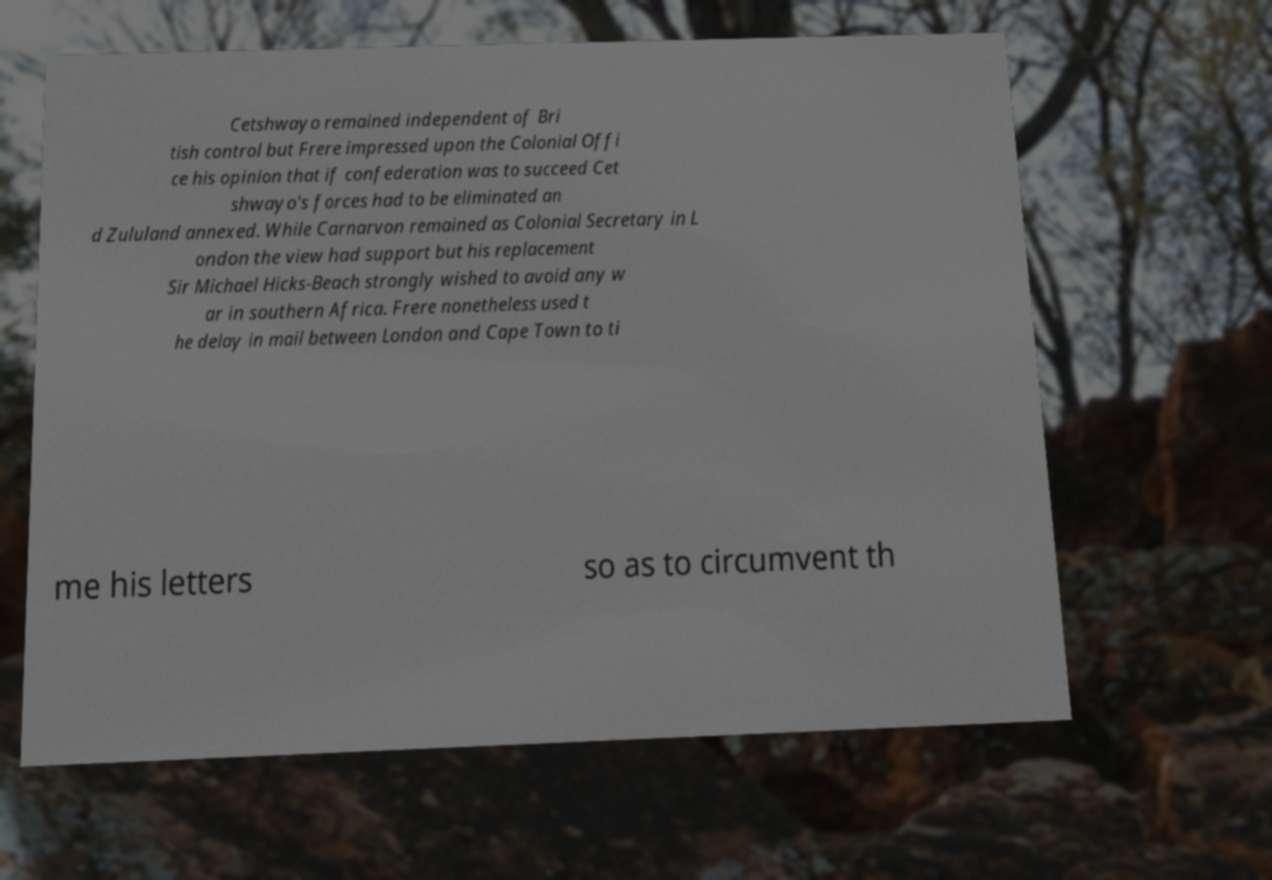Can you accurately transcribe the text from the provided image for me? Cetshwayo remained independent of Bri tish control but Frere impressed upon the Colonial Offi ce his opinion that if confederation was to succeed Cet shwayo's forces had to be eliminated an d Zululand annexed. While Carnarvon remained as Colonial Secretary in L ondon the view had support but his replacement Sir Michael Hicks-Beach strongly wished to avoid any w ar in southern Africa. Frere nonetheless used t he delay in mail between London and Cape Town to ti me his letters so as to circumvent th 